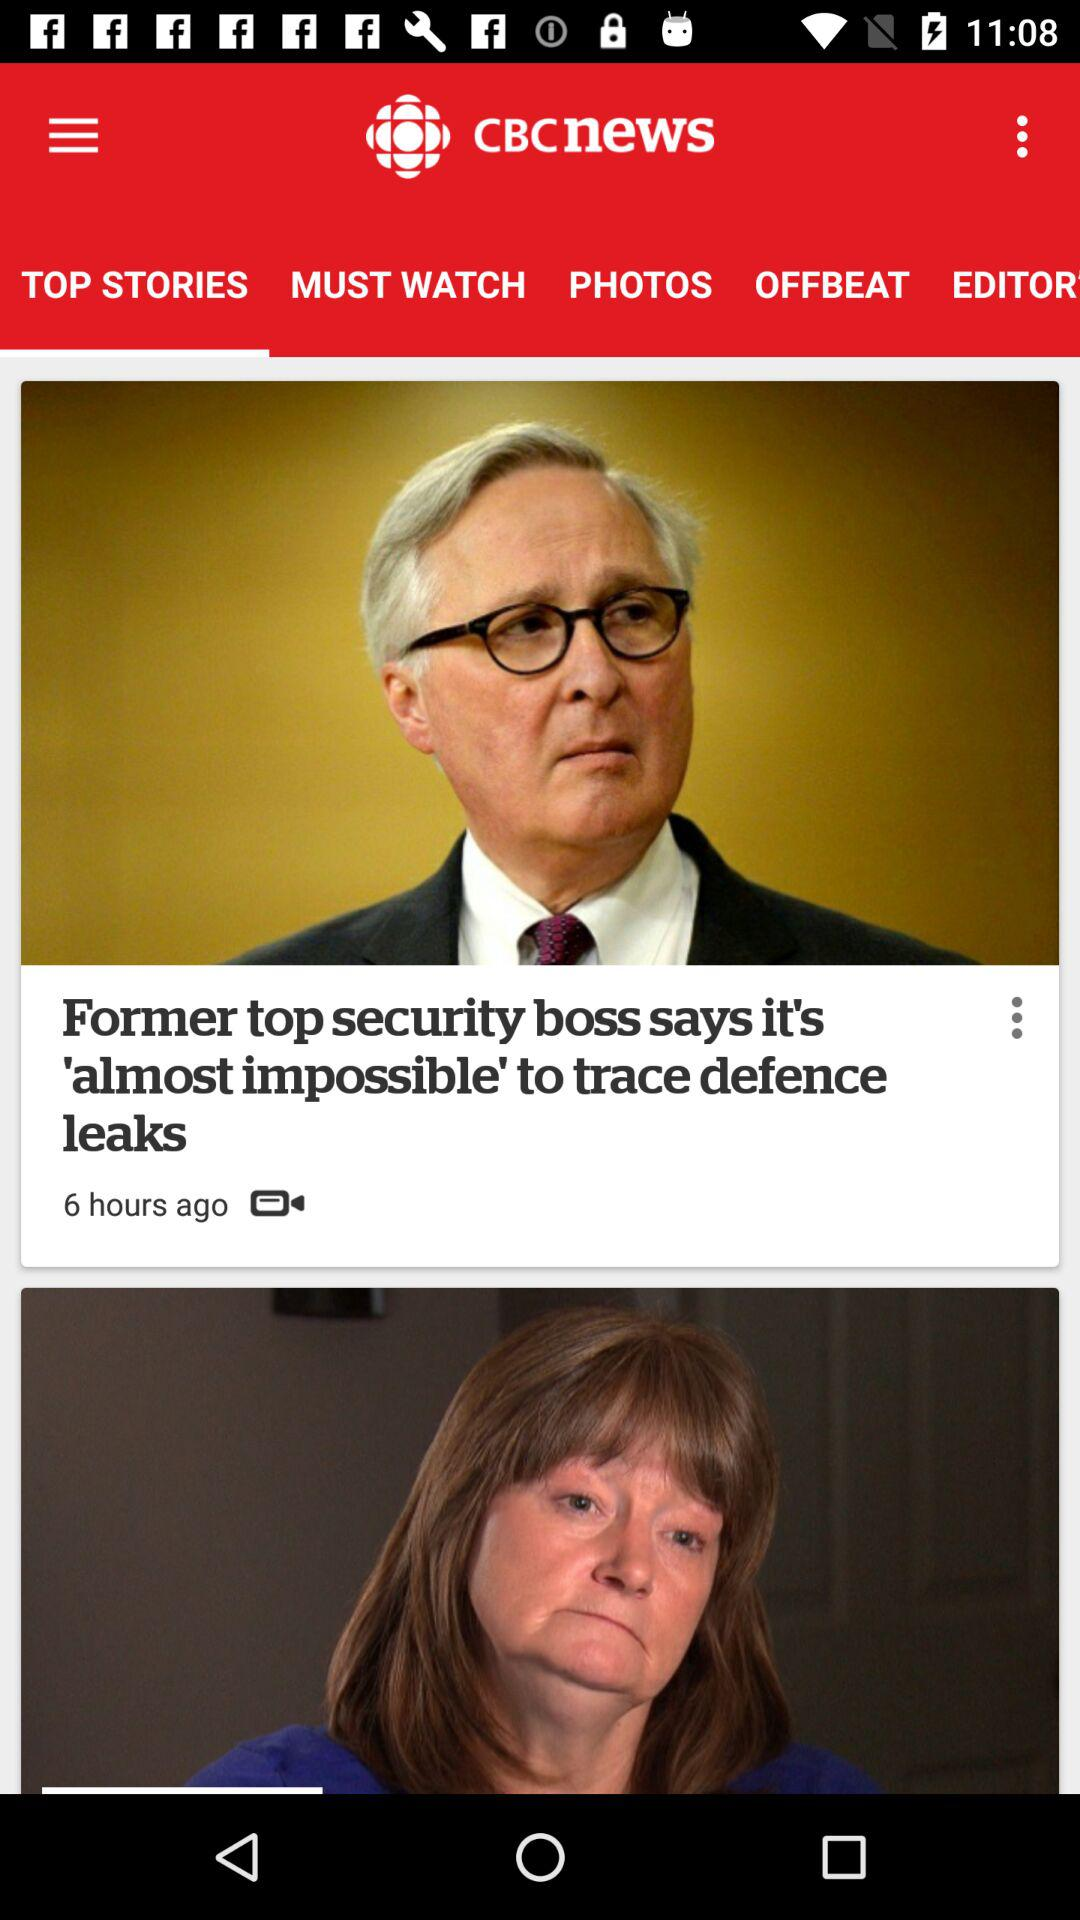When was the video posted? The video was posted 6 hours ago. 